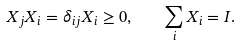<formula> <loc_0><loc_0><loc_500><loc_500>X _ { j } X _ { i } = \delta _ { i j } X _ { i } \geq 0 , \quad \sum _ { i } X _ { i } = I .</formula> 